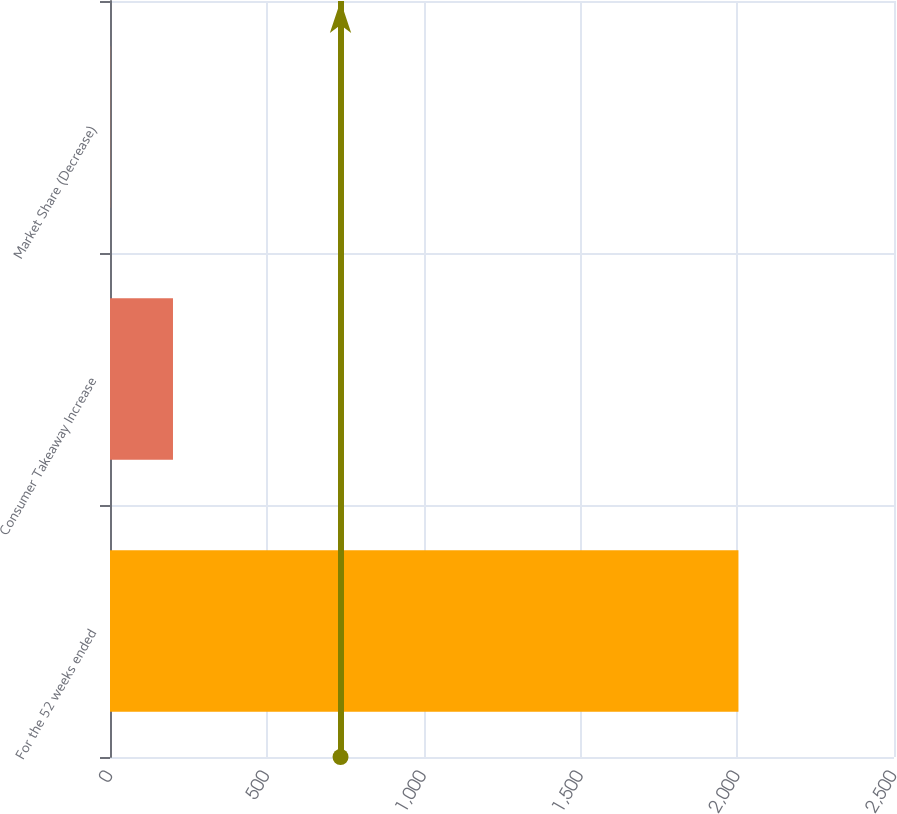Convert chart to OTSL. <chart><loc_0><loc_0><loc_500><loc_500><bar_chart><fcel>For the 52 weeks ended<fcel>Consumer Takeaway Increase<fcel>Market Share (Decrease)<nl><fcel>2004<fcel>200.85<fcel>0.5<nl></chart> 